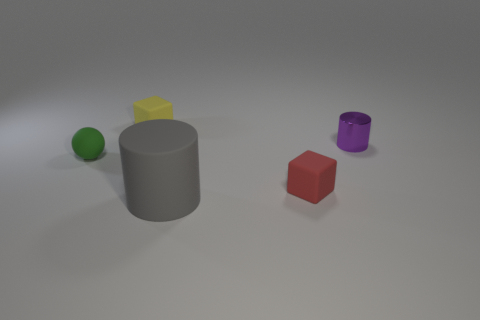There is a yellow object that is the same size as the green object; what is its material?
Make the answer very short. Rubber. There is a thing that is behind the small green object and in front of the yellow object; what material is it made of?
Provide a succinct answer. Metal. Are there any big gray metal objects?
Your response must be concise. No. Are there any other things that are the same shape as the green rubber thing?
Ensure brevity in your answer.  No. What shape is the tiny matte object to the right of the cylinder that is on the left side of the small object right of the tiny red thing?
Your response must be concise. Cube. What is the shape of the large gray rubber object?
Make the answer very short. Cylinder. The matte cube left of the big gray object is what color?
Offer a very short reply. Yellow. Do the rubber cube that is behind the green rubber object and the rubber sphere have the same size?
Your response must be concise. Yes. There is another rubber object that is the same shape as the yellow rubber thing; what is its size?
Keep it short and to the point. Small. Is there anything else that has the same size as the gray cylinder?
Offer a terse response. No. 